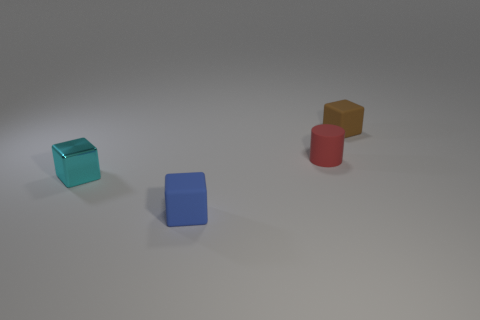What number of cylinders are either small brown matte things or small red matte things?
Give a very brief answer. 1. What number of tiny cubes are both right of the cyan metallic thing and on the left side of the red thing?
Offer a very short reply. 1. Is the size of the cylinder the same as the block on the left side of the small blue matte thing?
Keep it short and to the point. Yes. Is there a small cylinder left of the small matte cube that is on the right side of the matte cube that is to the left of the brown object?
Keep it short and to the point. Yes. What material is the small block on the right side of the small matte cube that is in front of the small metal cube made of?
Provide a succinct answer. Rubber. What material is the cube that is behind the blue rubber object and on the left side of the tiny brown matte thing?
Your answer should be very brief. Metal. Are there any other matte things of the same shape as the tiny blue rubber thing?
Provide a short and direct response. Yes. There is a rubber block in front of the tiny metal block; is there a blue matte block to the left of it?
Ensure brevity in your answer.  No. How many tiny blue objects have the same material as the small cyan object?
Offer a very short reply. 0. Are there any small brown rubber things?
Your response must be concise. Yes. 